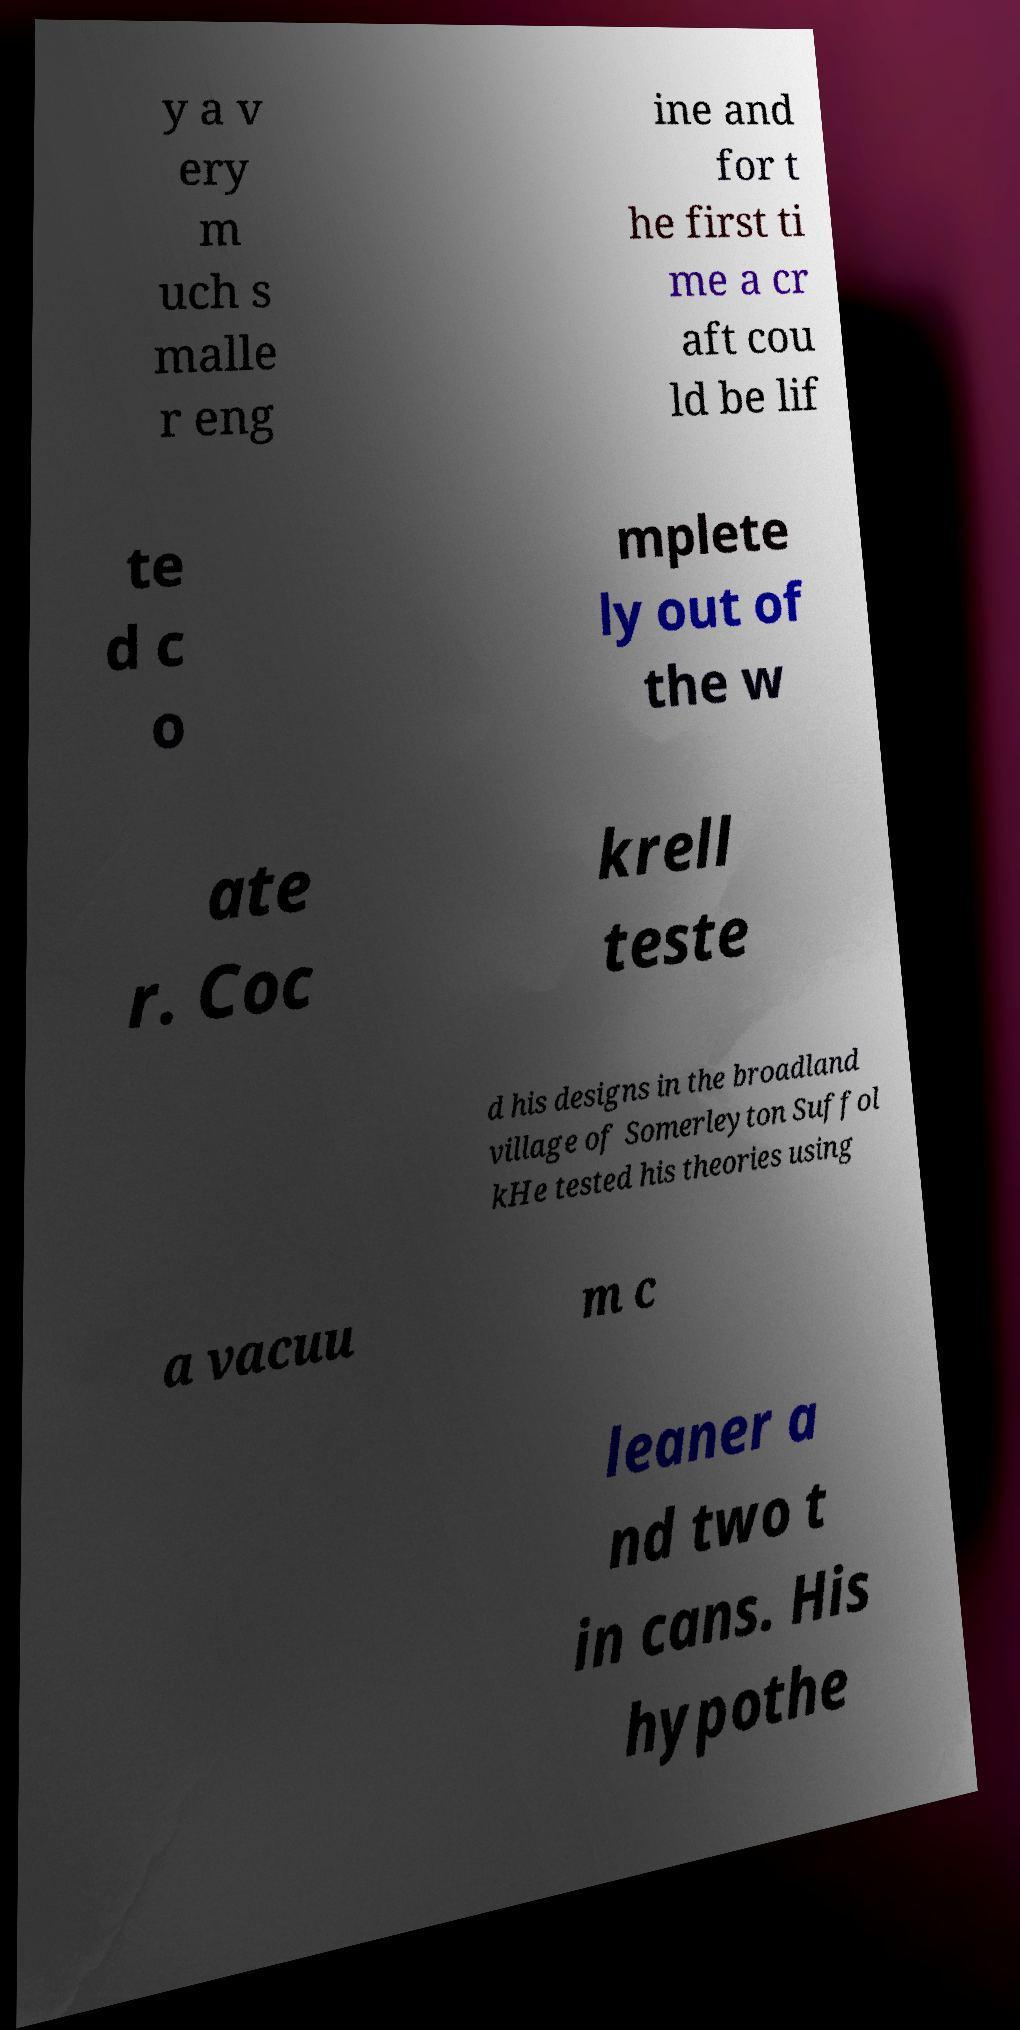There's text embedded in this image that I need extracted. Can you transcribe it verbatim? y a v ery m uch s malle r eng ine and for t he first ti me a cr aft cou ld be lif te d c o mplete ly out of the w ate r. Coc krell teste d his designs in the broadland village of Somerleyton Suffol kHe tested his theories using a vacuu m c leaner a nd two t in cans. His hypothe 